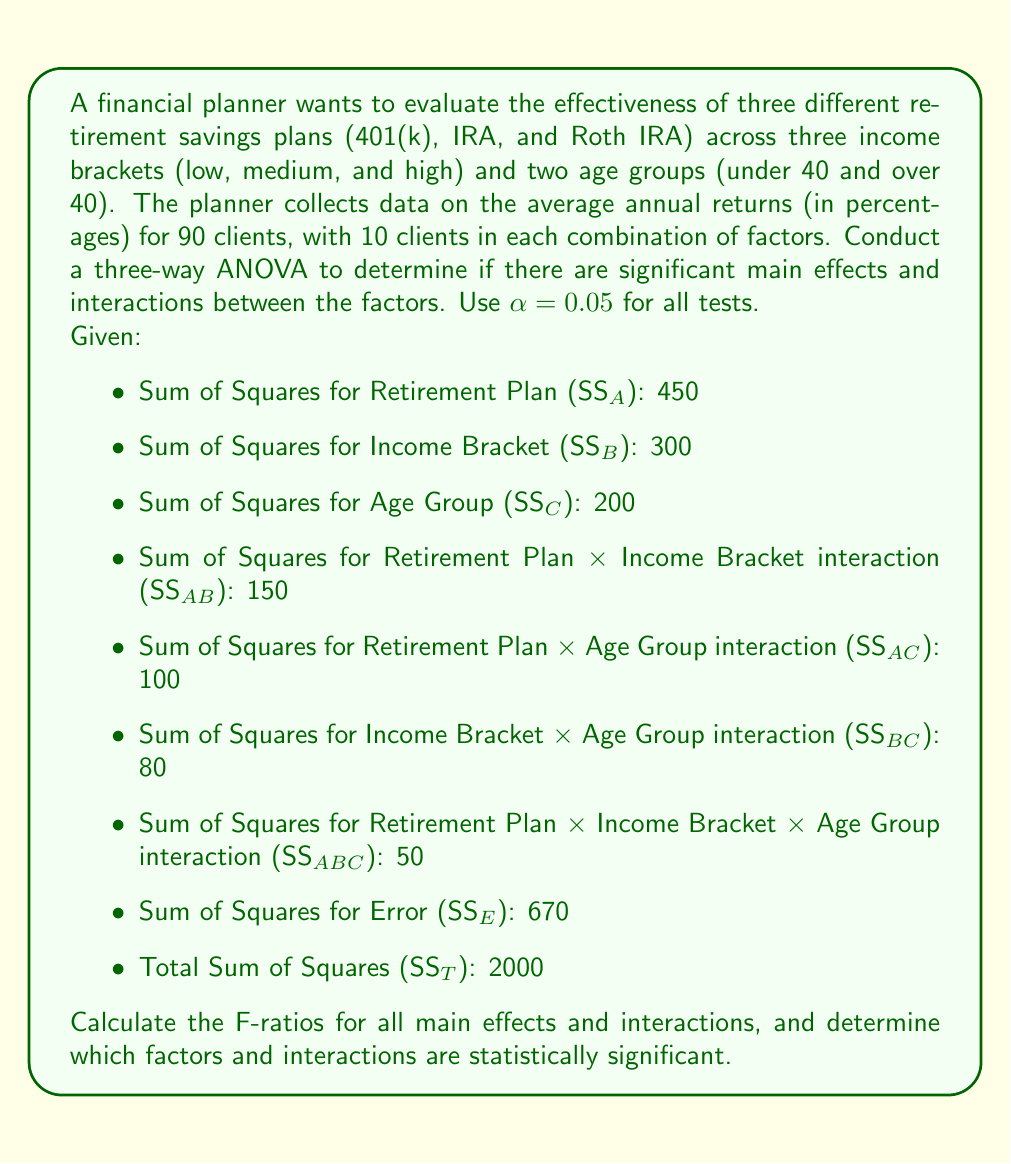Give your solution to this math problem. To solve this problem, we need to follow these steps:

1. Calculate the degrees of freedom (df) for each factor and interaction:
   - Retirement Plan (A): $df_A = 3 - 1 = 2$
   - Income Bracket (B): $df_B = 3 - 1 = 2$
   - Age Group (C): $df_C = 2 - 1 = 1$
   - A × B interaction: $df_{AB} = df_A \times df_B = 2 \times 2 = 4$
   - A × C interaction: $df_{AC} = df_A \times df_C = 2 \times 1 = 2$
   - B × C interaction: $df_{BC} = df_B \times df_C = 2 \times 1 = 2$
   - A × B × C interaction: $df_{ABC} = df_A \times df_B \times df_C = 2 \times 2 \times 1 = 4$
   - Error: $df_E = 90 - (3 \times 3 \times 2) = 72$
   - Total: $df_T = 90 - 1 = 89$

2. Calculate Mean Squares (MS) for each factor and interaction:
   $MS = \frac{SS}{df}$
   
   $MS_A = \frac{450}{2} = 225$
   $MS_B = \frac{300}{2} = 150$
   $MS_C = \frac{200}{1} = 200$
   $MS_{AB} = \frac{150}{4} = 37.5$
   $MS_{AC} = \frac{100}{2} = 50$
   $MS_{BC} = \frac{80}{2} = 40$
   $MS_{ABC} = \frac{50}{4} = 12.5$
   $MS_E = \frac{670}{72} = 9.31$

3. Calculate F-ratios:
   $F = \frac{MS_{factor}}{MS_E}$
   
   $F_A = \frac{225}{9.31} = 24.17$
   $F_B = \frac{150}{9.31} = 16.11$
   $F_C = \frac{200}{9.31} = 21.48$
   $F_{AB} = \frac{37.5}{9.31} = 4.03$
   $F_{AC} = \frac{50}{9.31} = 5.37$
   $F_{BC} = \frac{40}{9.31} = 4.30$
   $F_{ABC} = \frac{12.5}{9.31} = 1.34$

4. Determine critical F-values:
   For α = 0.05, we need to find the following critical F-values:
   $F_{crit(2,72)} = 3.12$ (for A, B, AB)
   $F_{crit(1,72)} = 3.97$ (for C, AC, BC)
   $F_{crit(4,72)} = 2.50$ (for ABC)

5. Compare F-ratios to critical F-values:
   - Retirement Plan (A): $24.17 > 3.12$ (significant)
   - Income Bracket (B): $16.11 > 3.12$ (significant)
   - Age Group (C): $21.48 > 3.97$ (significant)
   - A × B interaction: $4.03 > 3.12$ (significant)
   - A × C interaction: $5.37 > 3.97$ (significant)
   - B × C interaction: $4.30 > 3.97$ (significant)
   - A × B × C interaction: $1.34 < 2.50$ (not significant)
Answer: The analysis reveals that all main effects (Retirement Plan, Income Bracket, and Age Group) and two-way interactions (Retirement Plan × Income Bracket, Retirement Plan × Age Group, and Income Bracket × Age Group) are statistically significant at α = 0.05. The three-way interaction (Retirement Plan × Income Bracket × Age Group) is not statistically significant. This suggests that the effectiveness of retirement savings plans varies significantly across different income brackets and age groups, and these factors interact in complex ways. However, the combination of all three factors does not provide additional significant information beyond their individual effects and two-way interactions. 